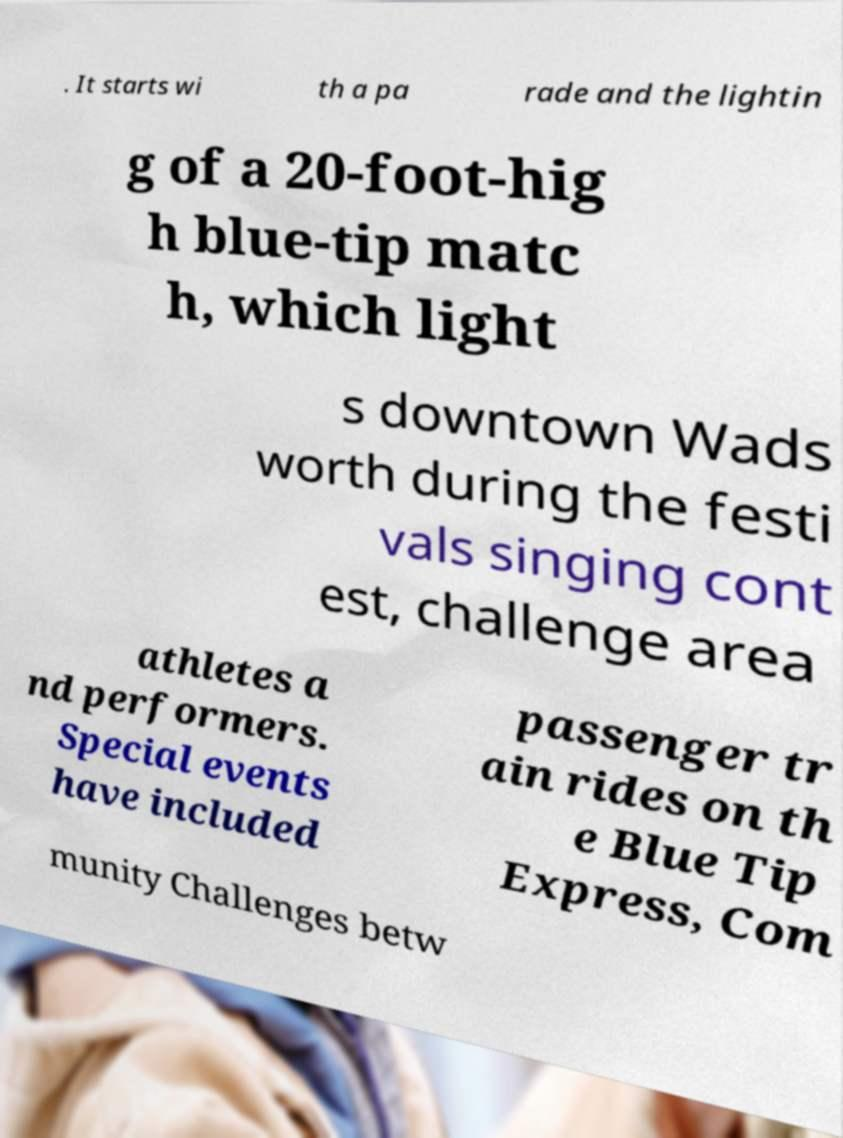For documentation purposes, I need the text within this image transcribed. Could you provide that? . It starts wi th a pa rade and the lightin g of a 20-foot-hig h blue-tip matc h, which light s downtown Wads worth during the festi vals singing cont est, challenge area athletes a nd performers. Special events have included passenger tr ain rides on th e Blue Tip Express, Com munity Challenges betw 